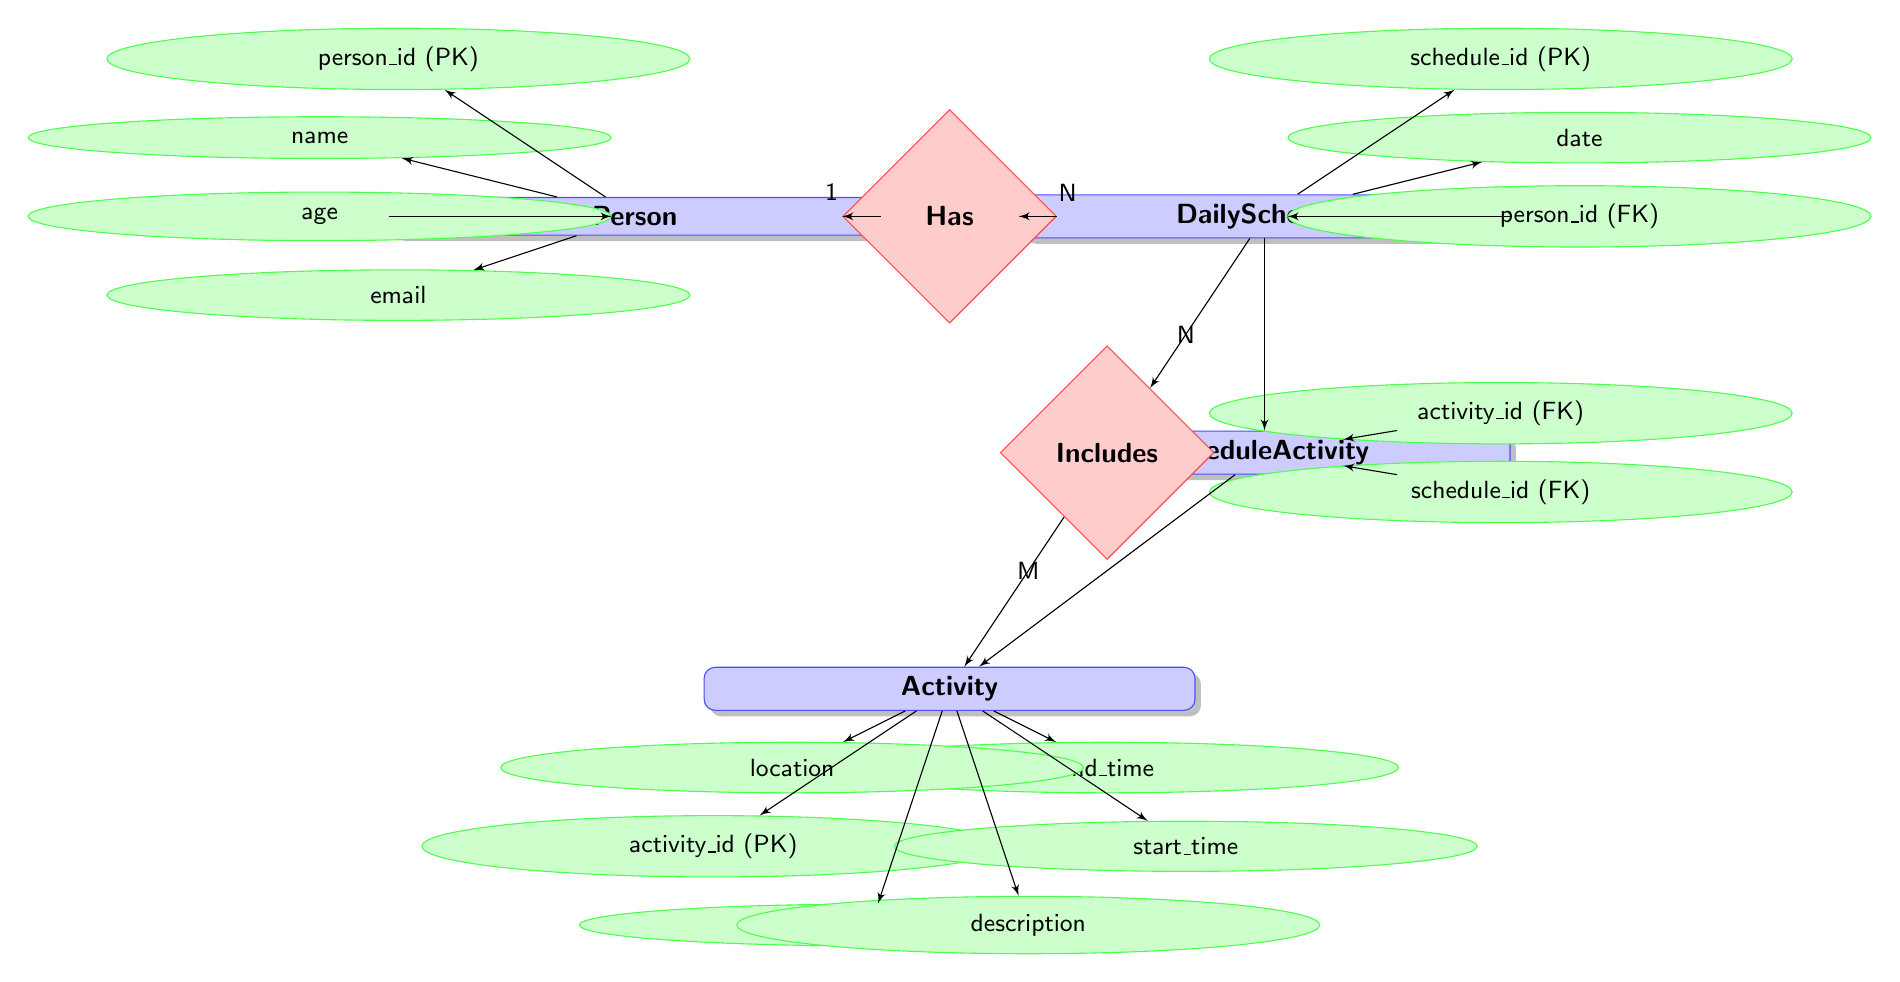What is the primary key of the Person entity? The primary key for the Person entity is indicated by "(PK)" next to the attribute name, which is "person_id".
Answer: person_id How many relationships are there in the diagram? The diagram shows two distinct relationships: "Has" and "Includes". Counting them gives us a total of two relationships.
Answer: 2 What is the cardinality between Person and DailySchedule? The diagram specifies that the relationship "Has" has a cardinality of one-to-many (1:N) indicated by the numbers 1 and N near the respective entities.
Answer: 1 to many Which entities are involved in the relationship named "Includes"? The relationship "Includes" involves the DailySchedule and Activity entities, as indicated in the relationship's labeling.
Answer: DailySchedule and Activity How many attributes does the Activity entity have? The attributes listed under the Activity entity include activity_id, name, description, start_time, end_time, and location. There are a total of six attributes.
Answer: 6 What type of relationship is depicted between DailySchedule and Activity? The diagram shows a many-to-many relationship between DailySchedule and Activity, which is indicated by the relationship labeled "Includes".
Answer: Many-to-many What is the foreign key in DailySchedule? The foreign key in the DailySchedule entity is "person_id", as indicated by "(FK)" next to the attribute name, which links to the Person entity.
Answer: person_id Which entity has more attributes, Person or Activity? Counting the attributes, the Person entity has four attributes while the Activity entity has six attributes. Therefore, the Activity entity has more attributes.
Answer: Activity How does the ScheduleActivity entity connect DailySchedule and Activity? The ScheduleActivity entity acts as a junction table to facilitate the many-to-many relationship between DailySchedule and Activity, containing foreign keys for both.
Answer: By acting as a junction table 